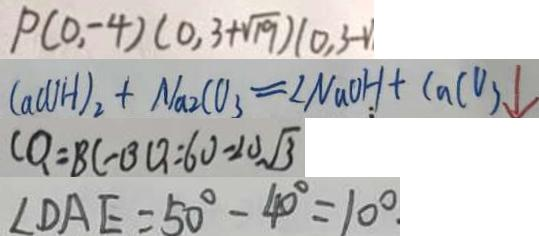<formula> <loc_0><loc_0><loc_500><loc_500>P ( 0 , - 4 ) ( 0 , 3 + \sqrt { 1 9 } ) ( 0 , 3 - 1 ) 
 C a ( O H ) _ { 2 } + N a 2 C O _ { 3 } = \angle N a O H + C a C O _ { 3 } \downarrow 
 C Q = B C - B Q = 6 0 - 2 0 \sqrt { 3 } 
 \angle D A E = 5 0 ^ { \circ } - 4 0 ^ { \circ } = 1 0 ^ { \circ }</formula> 